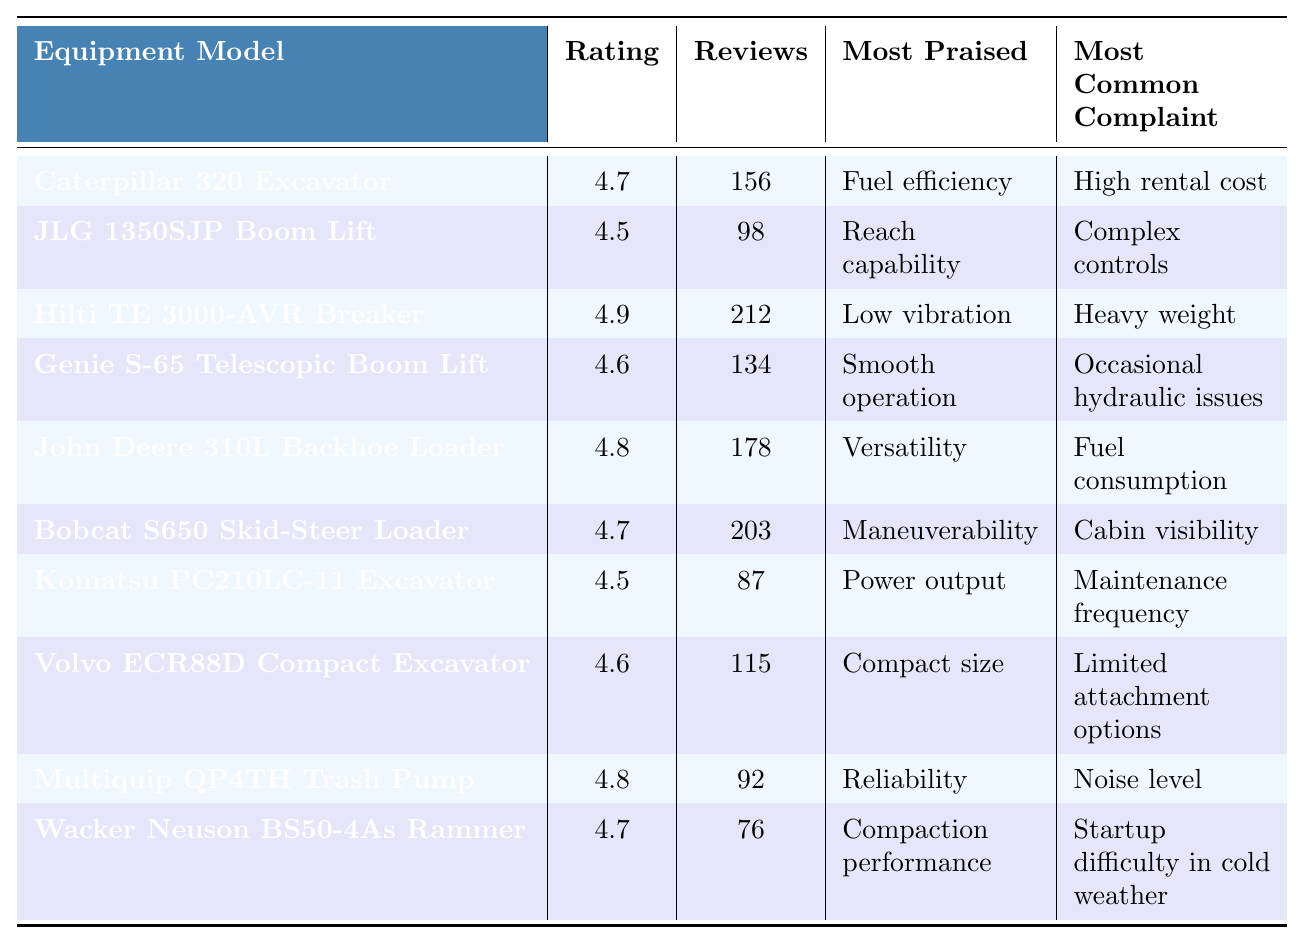What is the customer satisfaction rating for the Hilti TE 3000-AVR Breaker? According to the table, the rating is specifically listed under the "Customer Satisfaction Rating" column for the Hilti TE 3000-AVR Breaker. It shows a rating of 4.9.
Answer: 4.9 Which equipment model has the highest number of reviews? By reviewing the "Number of Reviews" column, I find that the Hilti TE 3000-AVR Breaker has the highest number of reviews, with a total of 212.
Answer: Hilti TE 3000-AVR Breaker What feature is most commonly praised for the John Deere 310L Backhoe Loader? In the table, the "Most Praised Feature" column indicates that the John Deere 310L Backhoe Loader is most appreciated for its versatility.
Answer: Versatility Is the customer satisfaction rating for the Volvo ECR88D Compact Excavator higher than 4.5? Looking at the "Customer Satisfaction Rating" for the Volvo ECR88D Compact Excavator, which is 4.6, I can conclude that it is indeed higher than 4.5.
Answer: Yes What is the average customer satisfaction rating for all the equipment models in the table? To calculate the average, sum the ratings (4.7 + 4.5 + 4.9 + 4.6 + 4.8 + 4.7 + 4.5 + 4.6 + 4.8 + 4.7), which equals 47.5, and divide by the number of models (10). Thus, the average rating is 47.5 / 10 = 4.75.
Answer: 4.75 How many equipment models have a customer satisfaction rating of 4.7 or higher? By checking the "Customer Satisfaction Rating" column, I see that the following models have a rating of 4.7 or higher: Caterpillar 320 Excavator, Hilti TE 3000-AVR Breaker, John Deere 310L Backhoe Loader, Bobcat S650 Skid-Steer Loader, Multiquip QP4TH Trash Pump, and Wacker Neuson BS50-4As Rammer, totaling six models.
Answer: 6 What is the most common complaint across all equipment models? I will look through the "Most Common Complaint" column, where I will note the complaints presented. While reviewing them, "High rental cost" and "Complex controls" appear once, "Heavy weight" once, "Fuel consumption" once, "Cabin visibility" once, "Maintenance frequency" once, and "Noise level" once, while "Occasional hydraulic issues" and "Limited attachment options" also appear once. Hence, there isn't one dominant complaint as each appears only once.
Answer: No common complaint Which equipment models have a customer satisfaction rating of exactly 4.5? Looking at the "Customer Satisfaction Rating" column, Komatsu PC210LC-11 Excavator and JLG 1350SJP Boom Lift both have a rating of exactly 4.5, identifying them as the required models.
Answer: Komatsu PC210LC-11 Excavator, JLG 1350SJP Boom Lift What is the difference in customer satisfaction ratings between the Hilti TE 3000-AVR Breaker and the JLG 1350SJP Boom Lift? The rating for the Hilti TE 3000-AVR Breaker is 4.9, and for the JLG 1350SJP Boom Lift it is 4.5. Thus, the difference in ratings is 4.9 - 4.5, which equals 0.4.
Answer: 0.4 Which equipment model has the most praised feature related to fuel efficiency? Upon examining the "Most Praised Feature" column, the "Fuel efficiency" feature is specifically attributed to the Caterpillar 320 Excavator, making it the model in question.
Answer: Caterpillar 320 Excavator 